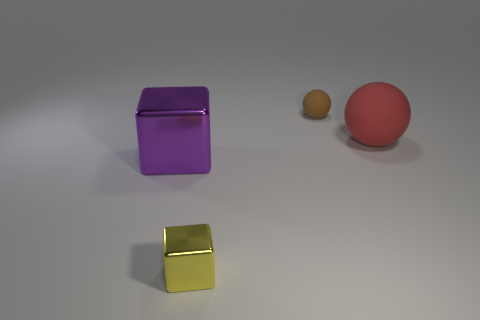Add 1 large purple cubes. How many large purple cubes exist? 2 Add 1 big balls. How many objects exist? 5 Subtract all yellow cubes. How many cubes are left? 1 Subtract 0 cyan blocks. How many objects are left? 4 Subtract 2 cubes. How many cubes are left? 0 Subtract all yellow cubes. Subtract all blue cylinders. How many cubes are left? 1 Subtract all large red matte objects. Subtract all brown things. How many objects are left? 2 Add 1 yellow metal objects. How many yellow metal objects are left? 2 